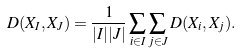Convert formula to latex. <formula><loc_0><loc_0><loc_500><loc_500>D ( X _ { I } , X _ { J } ) = \frac { 1 } { | I | | J | } \sum _ { i \in I } \sum _ { j \in J } D ( X _ { i } , X _ { j } ) .</formula> 